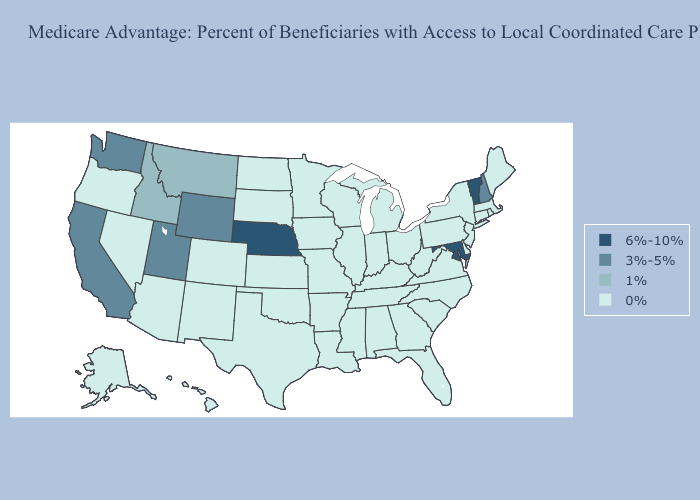What is the highest value in states that border Michigan?
Write a very short answer. 0%. Does Wisconsin have the highest value in the MidWest?
Short answer required. No. Which states hav the highest value in the Northeast?
Answer briefly. Vermont. What is the highest value in the MidWest ?
Give a very brief answer. 6%-10%. Does Connecticut have the lowest value in the Northeast?
Concise answer only. Yes. Does Arizona have the highest value in the USA?
Be succinct. No. Name the states that have a value in the range 1%?
Quick response, please. Idaho, Montana. Among the states that border Oklahoma , which have the highest value?
Write a very short answer. Colorado, Kansas, Missouri, New Mexico, Texas, Arkansas. Name the states that have a value in the range 1%?
Short answer required. Idaho, Montana. Does Kentucky have the lowest value in the South?
Keep it brief. Yes. What is the value of Nebraska?
Give a very brief answer. 6%-10%. Name the states that have a value in the range 6%-10%?
Give a very brief answer. Maryland, Nebraska, Vermont. Does Missouri have the lowest value in the USA?
Keep it brief. Yes. Which states hav the highest value in the South?
Quick response, please. Maryland. 